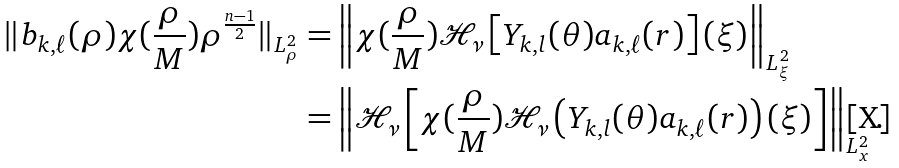Convert formula to latex. <formula><loc_0><loc_0><loc_500><loc_500>\| b _ { k , \ell } ( \rho ) \chi ( \frac { \rho } M ) \rho ^ { \frac { n - 1 } { 2 } } \| _ { L _ { \rho } ^ { 2 } } = & \left \| \chi ( \frac { \rho } M ) \mathcal { H } _ { \nu } \left [ Y _ { k , l } ( \theta ) a _ { k , \ell } ( r ) \right ] ( \xi ) \right \| _ { L _ { \xi } ^ { 2 } } \\ = & \left \| \mathcal { H } _ { \nu } \left [ \chi ( \frac { \rho } M ) \mathcal { H } _ { \nu } \left ( Y _ { k , l } ( \theta ) a _ { k , \ell } ( r ) \right ) ( \xi ) \right ] \right \| _ { L _ { x } ^ { 2 } } .</formula> 